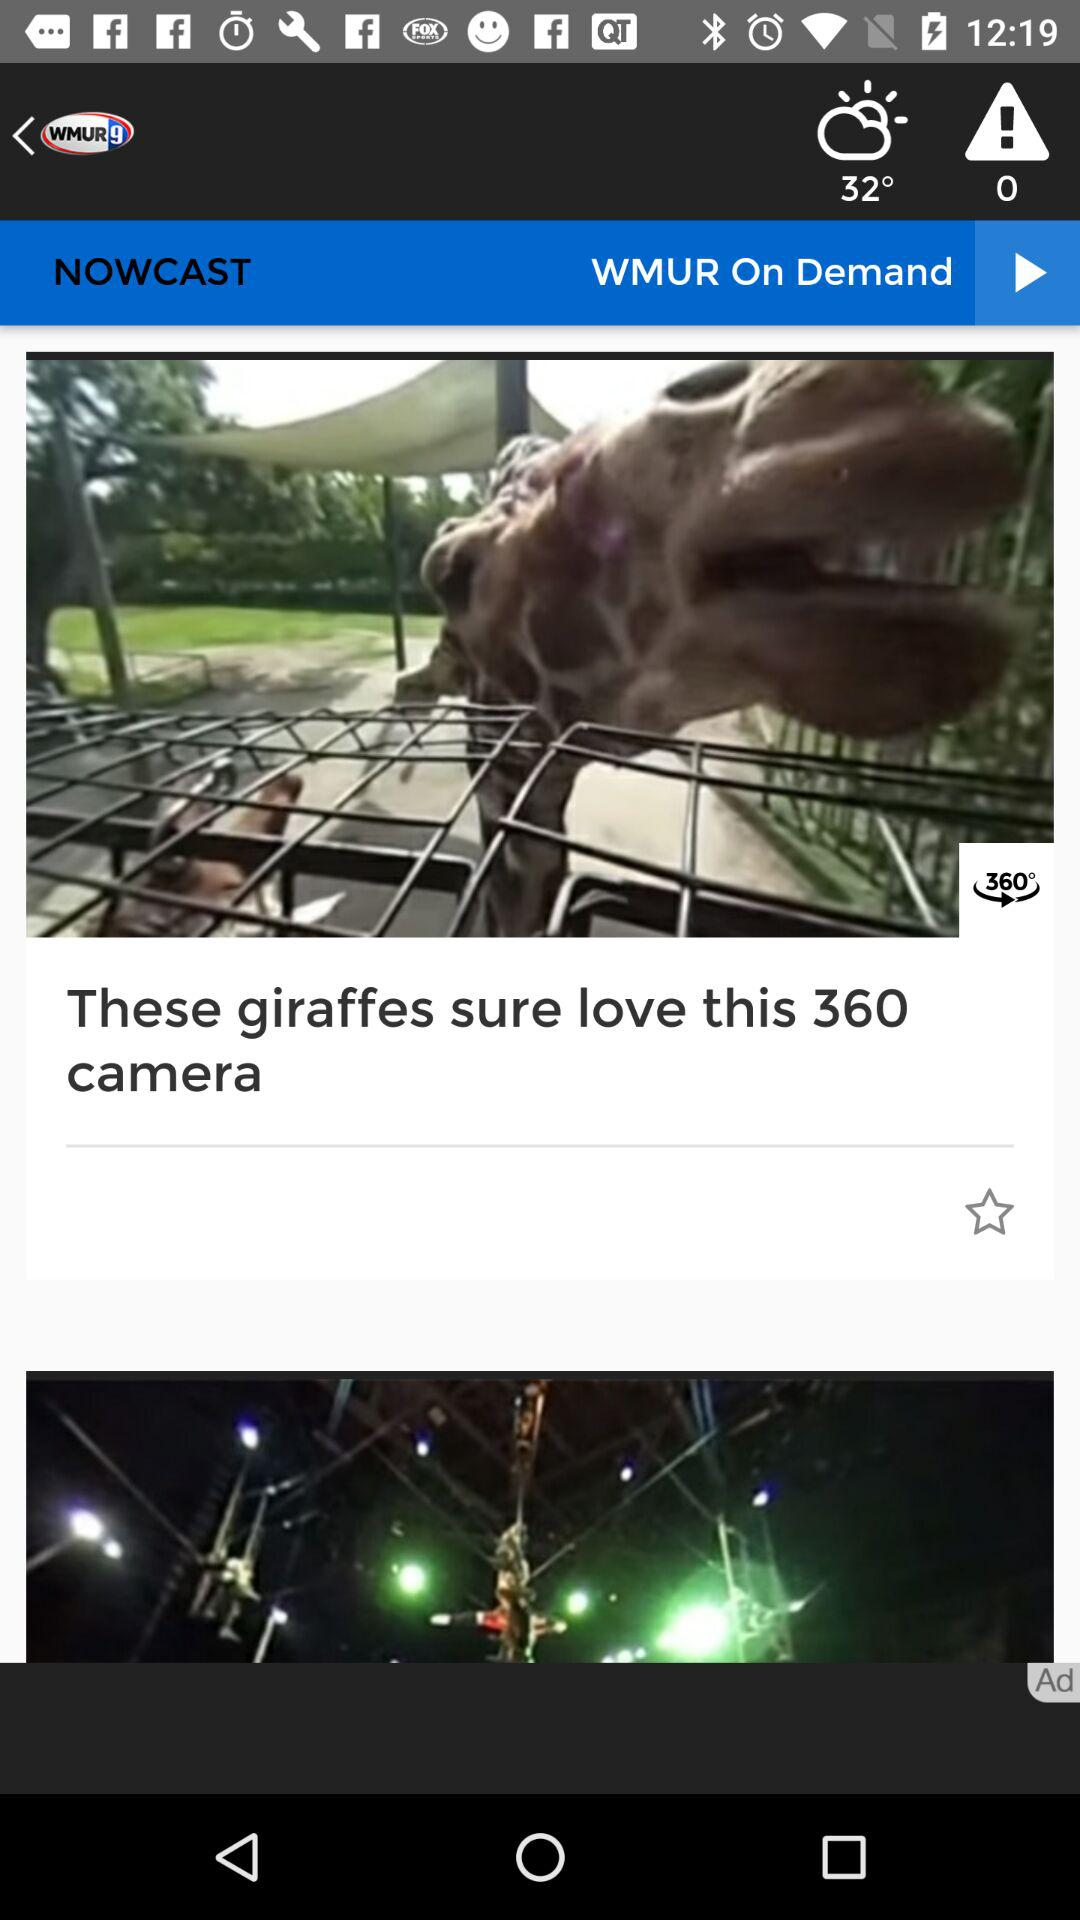What is the temperature? The temperature is 32°. 